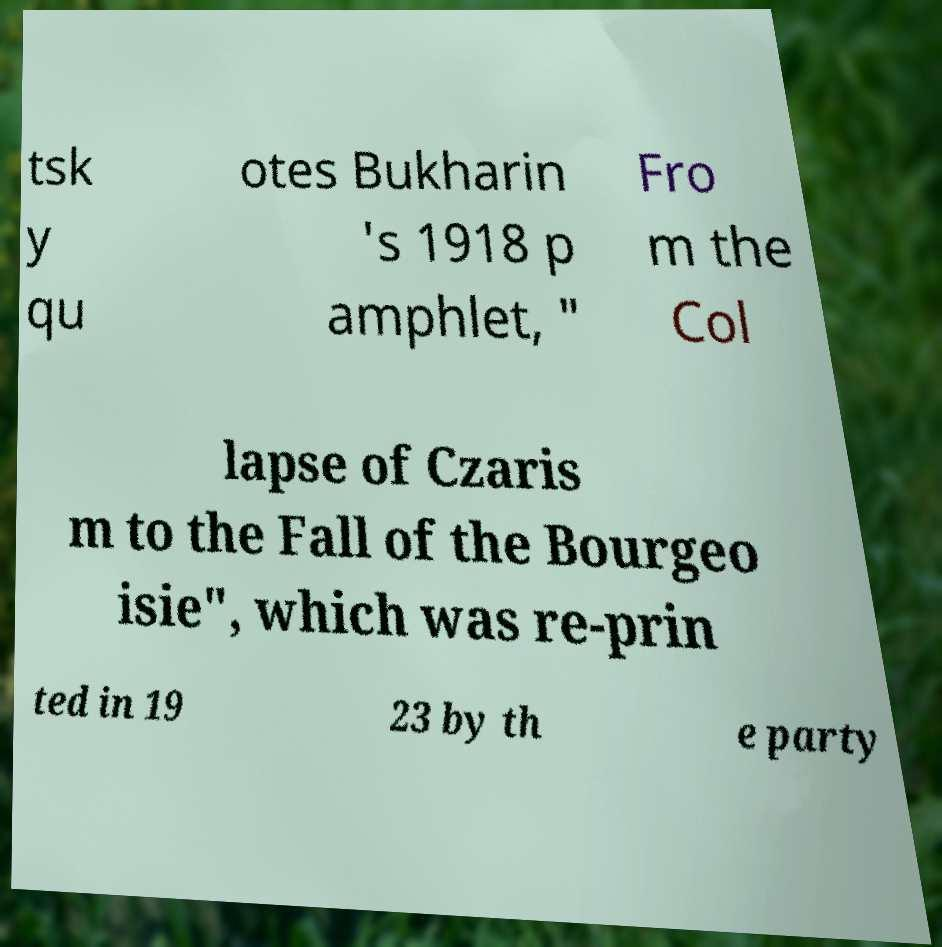Please identify and transcribe the text found in this image. tsk y qu otes Bukharin 's 1918 p amphlet, " Fro m the Col lapse of Czaris m to the Fall of the Bourgeo isie", which was re-prin ted in 19 23 by th e party 